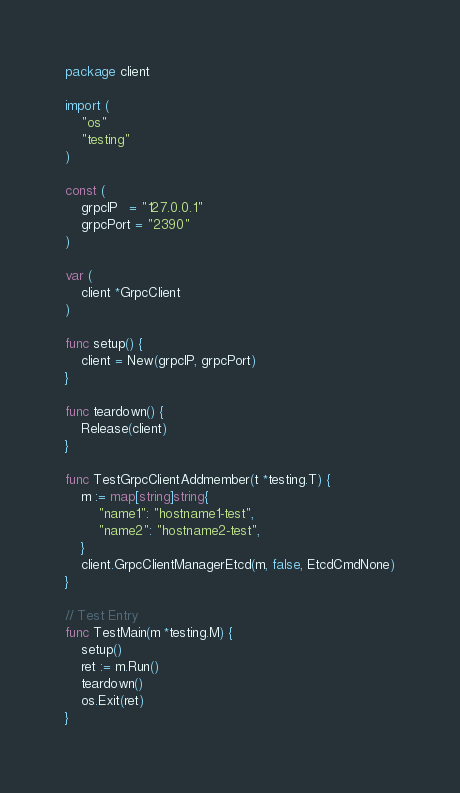Convert code to text. <code><loc_0><loc_0><loc_500><loc_500><_Go_>package client

import (
	"os"
	"testing"
)

const (
	grpcIP   = "127.0.0.1"
	grpcPort = "2390"
)

var (
	client *GrpcClient
)

func setup() {
	client = New(grpcIP, grpcPort)
}

func teardown() {
	Release(client)
}

func TestGrpcClientAddmember(t *testing.T) {
	m := map[string]string{
		"name1": "hostname1-test",
		"name2": "hostname2-test",
	}
	client.GrpcClientManagerEtcd(m, false, EtcdCmdNone)
}

// Test Entry
func TestMain(m *testing.M) {
	setup()
	ret := m.Run()
	teardown()
	os.Exit(ret)
}
</code> 